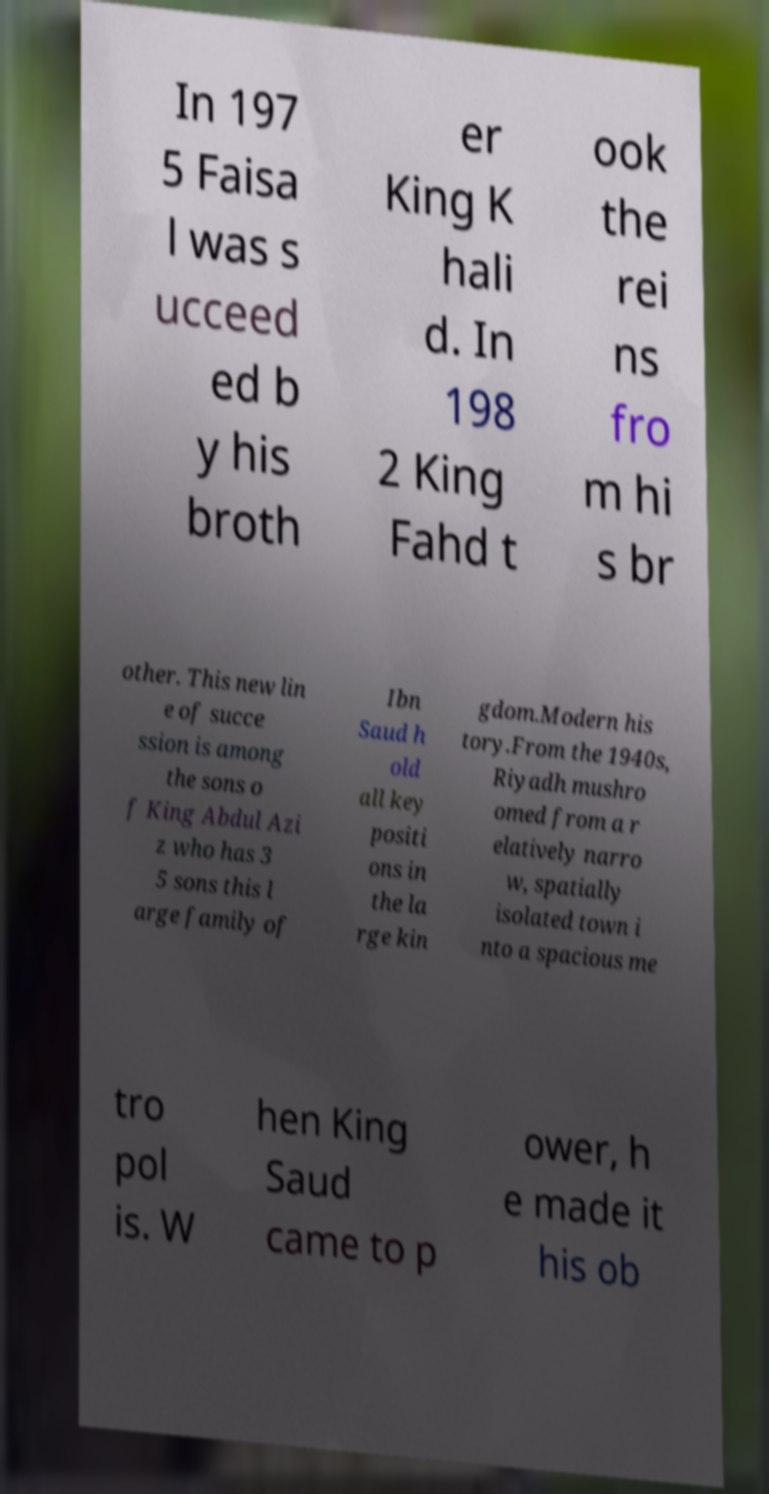Can you accurately transcribe the text from the provided image for me? In 197 5 Faisa l was s ucceed ed b y his broth er King K hali d. In 198 2 King Fahd t ook the rei ns fro m hi s br other. This new lin e of succe ssion is among the sons o f King Abdul Azi z who has 3 5 sons this l arge family of Ibn Saud h old all key positi ons in the la rge kin gdom.Modern his tory.From the 1940s, Riyadh mushro omed from a r elatively narro w, spatially isolated town i nto a spacious me tro pol is. W hen King Saud came to p ower, h e made it his ob 